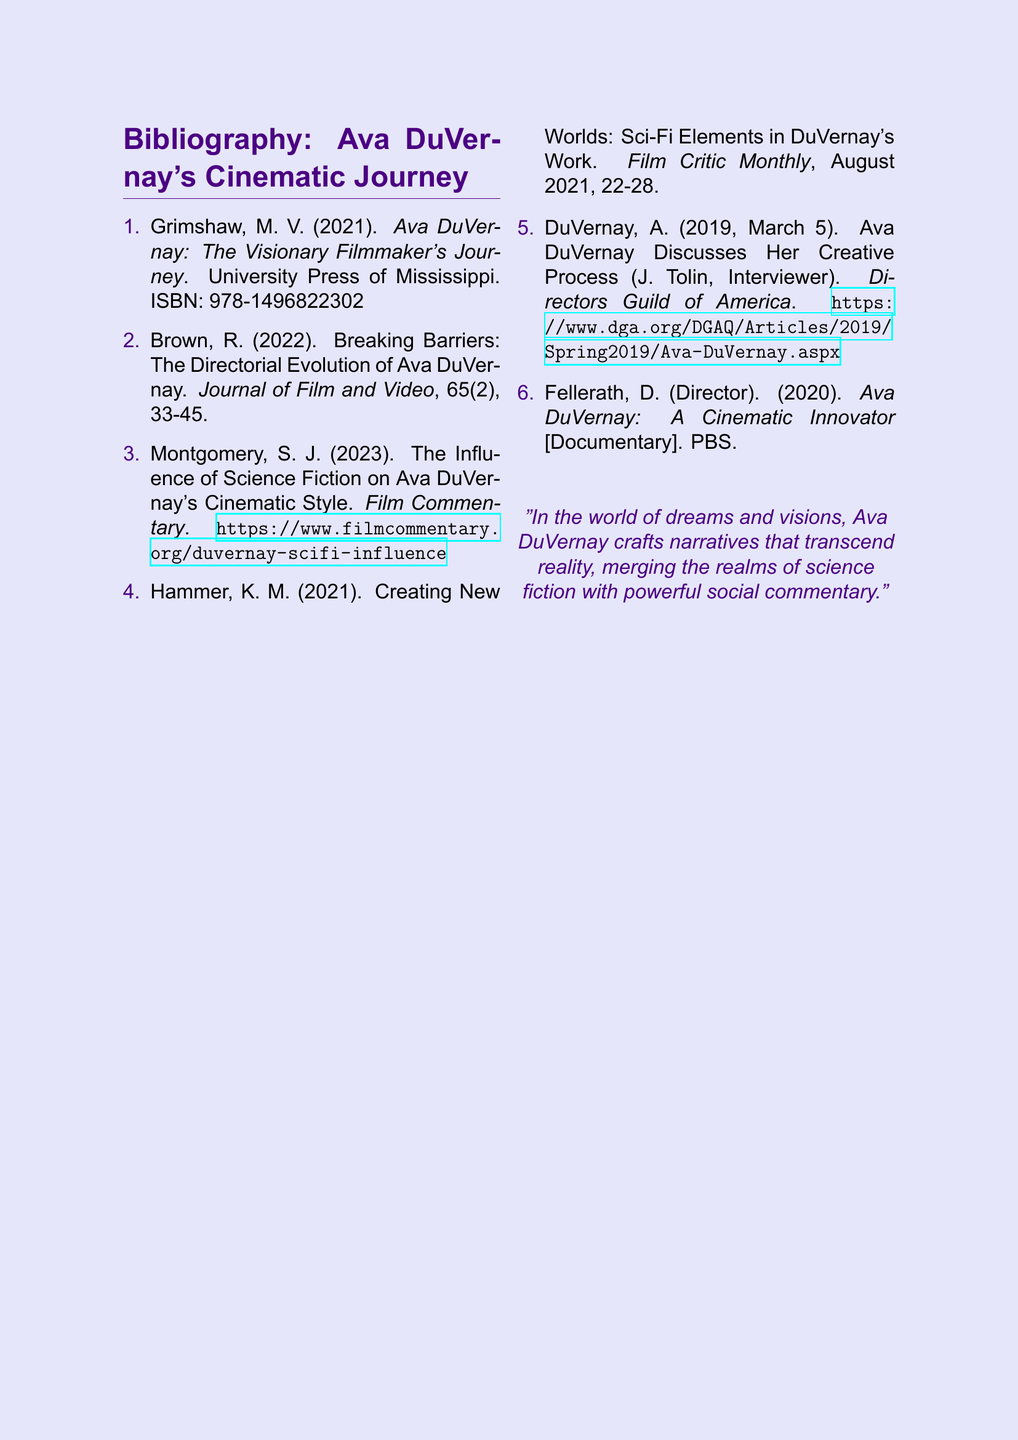what is the title of the first entry? The title of the first entry is the first film/reference listed in the bibliography.
Answer: Ava DuVernay: The Visionary Filmmaker's Journey who is the author of the second entry? The author of the second entry is listed next to the title of that particular work.
Answer: R. Brown what year was the documentary about Ava DuVernay released? The release year of the documentary is noted in the bibliographic entry.
Answer: 2020 how many entries are listed in total? The total number of entries is the count of all items in the bibliography.
Answer: 6 which publication featured the article about the influence of science fiction on DuVernay's style? The name of the publication is mentioned at the end of that citation.
Answer: Film Commentary who conducted the interview with Ava DuVernay in 2019? The interviewer is mentioned in the bibliographic entry next to Ava DuVernay’s name.
Answer: J. Tolin what is the main color theme used in the document? The main color theme can be inferred from the design choices in the document, particularly in headings.
Answer: spacepurple which month and day is the documentary's release date mentioned? The specific month and day give context to the documentary's release.
Answer: August 2021 